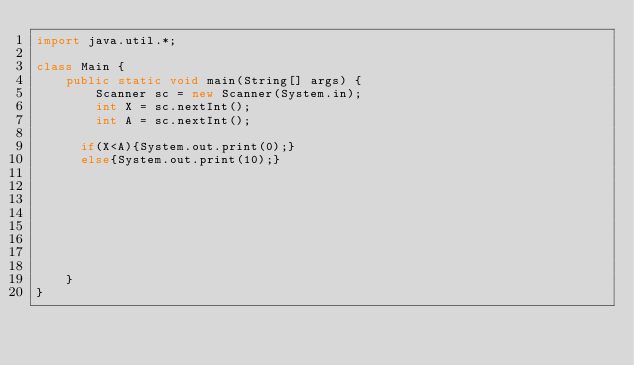<code> <loc_0><loc_0><loc_500><loc_500><_Java_>import java.util.*;
 
class Main {
    public static void main(String[] args) {
        Scanner sc = new Scanner(System.in);
        int X = sc.nextInt();
        int A = sc.nextInt();

      if(X<A){System.out.print(0);}
      else{System.out.print(10);}
      
      
      
      
      


      
    }
}</code> 